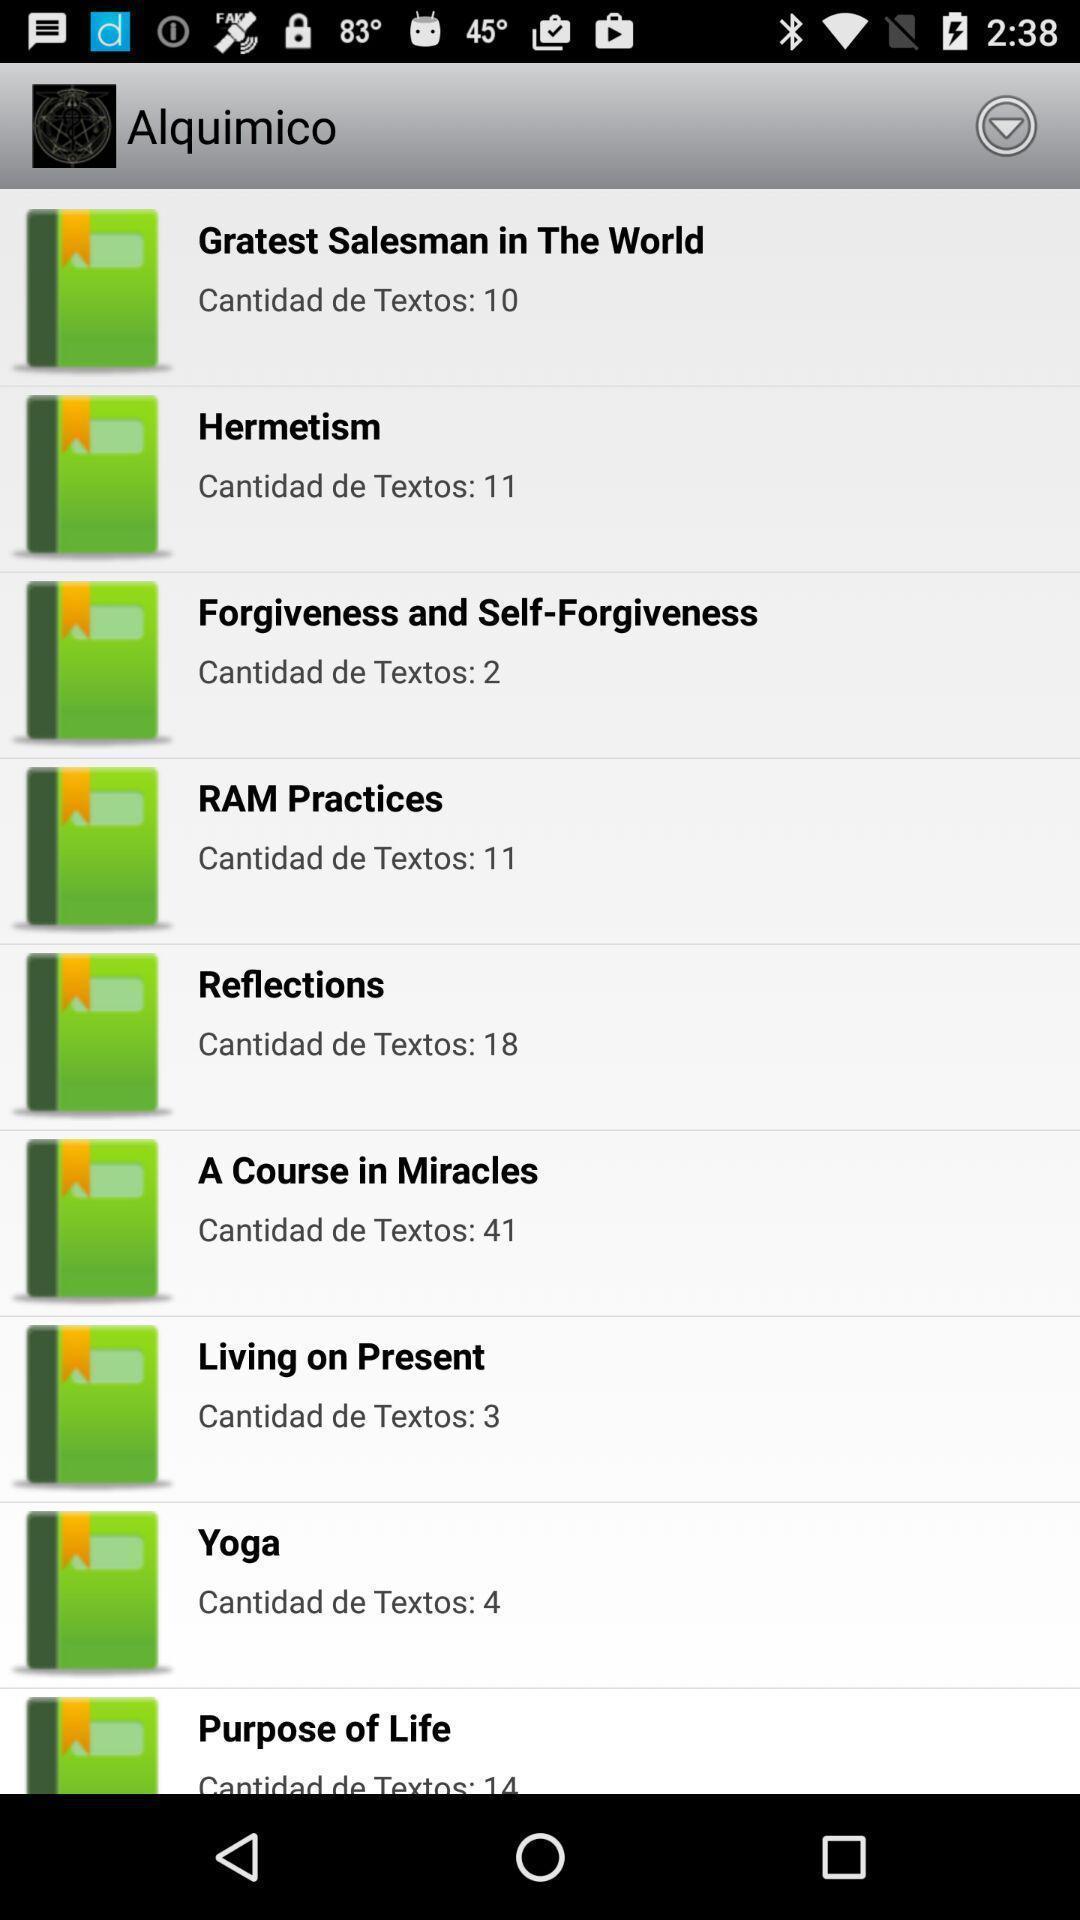Give me a summary of this screen capture. Screen displaying multiple bookmark names. 